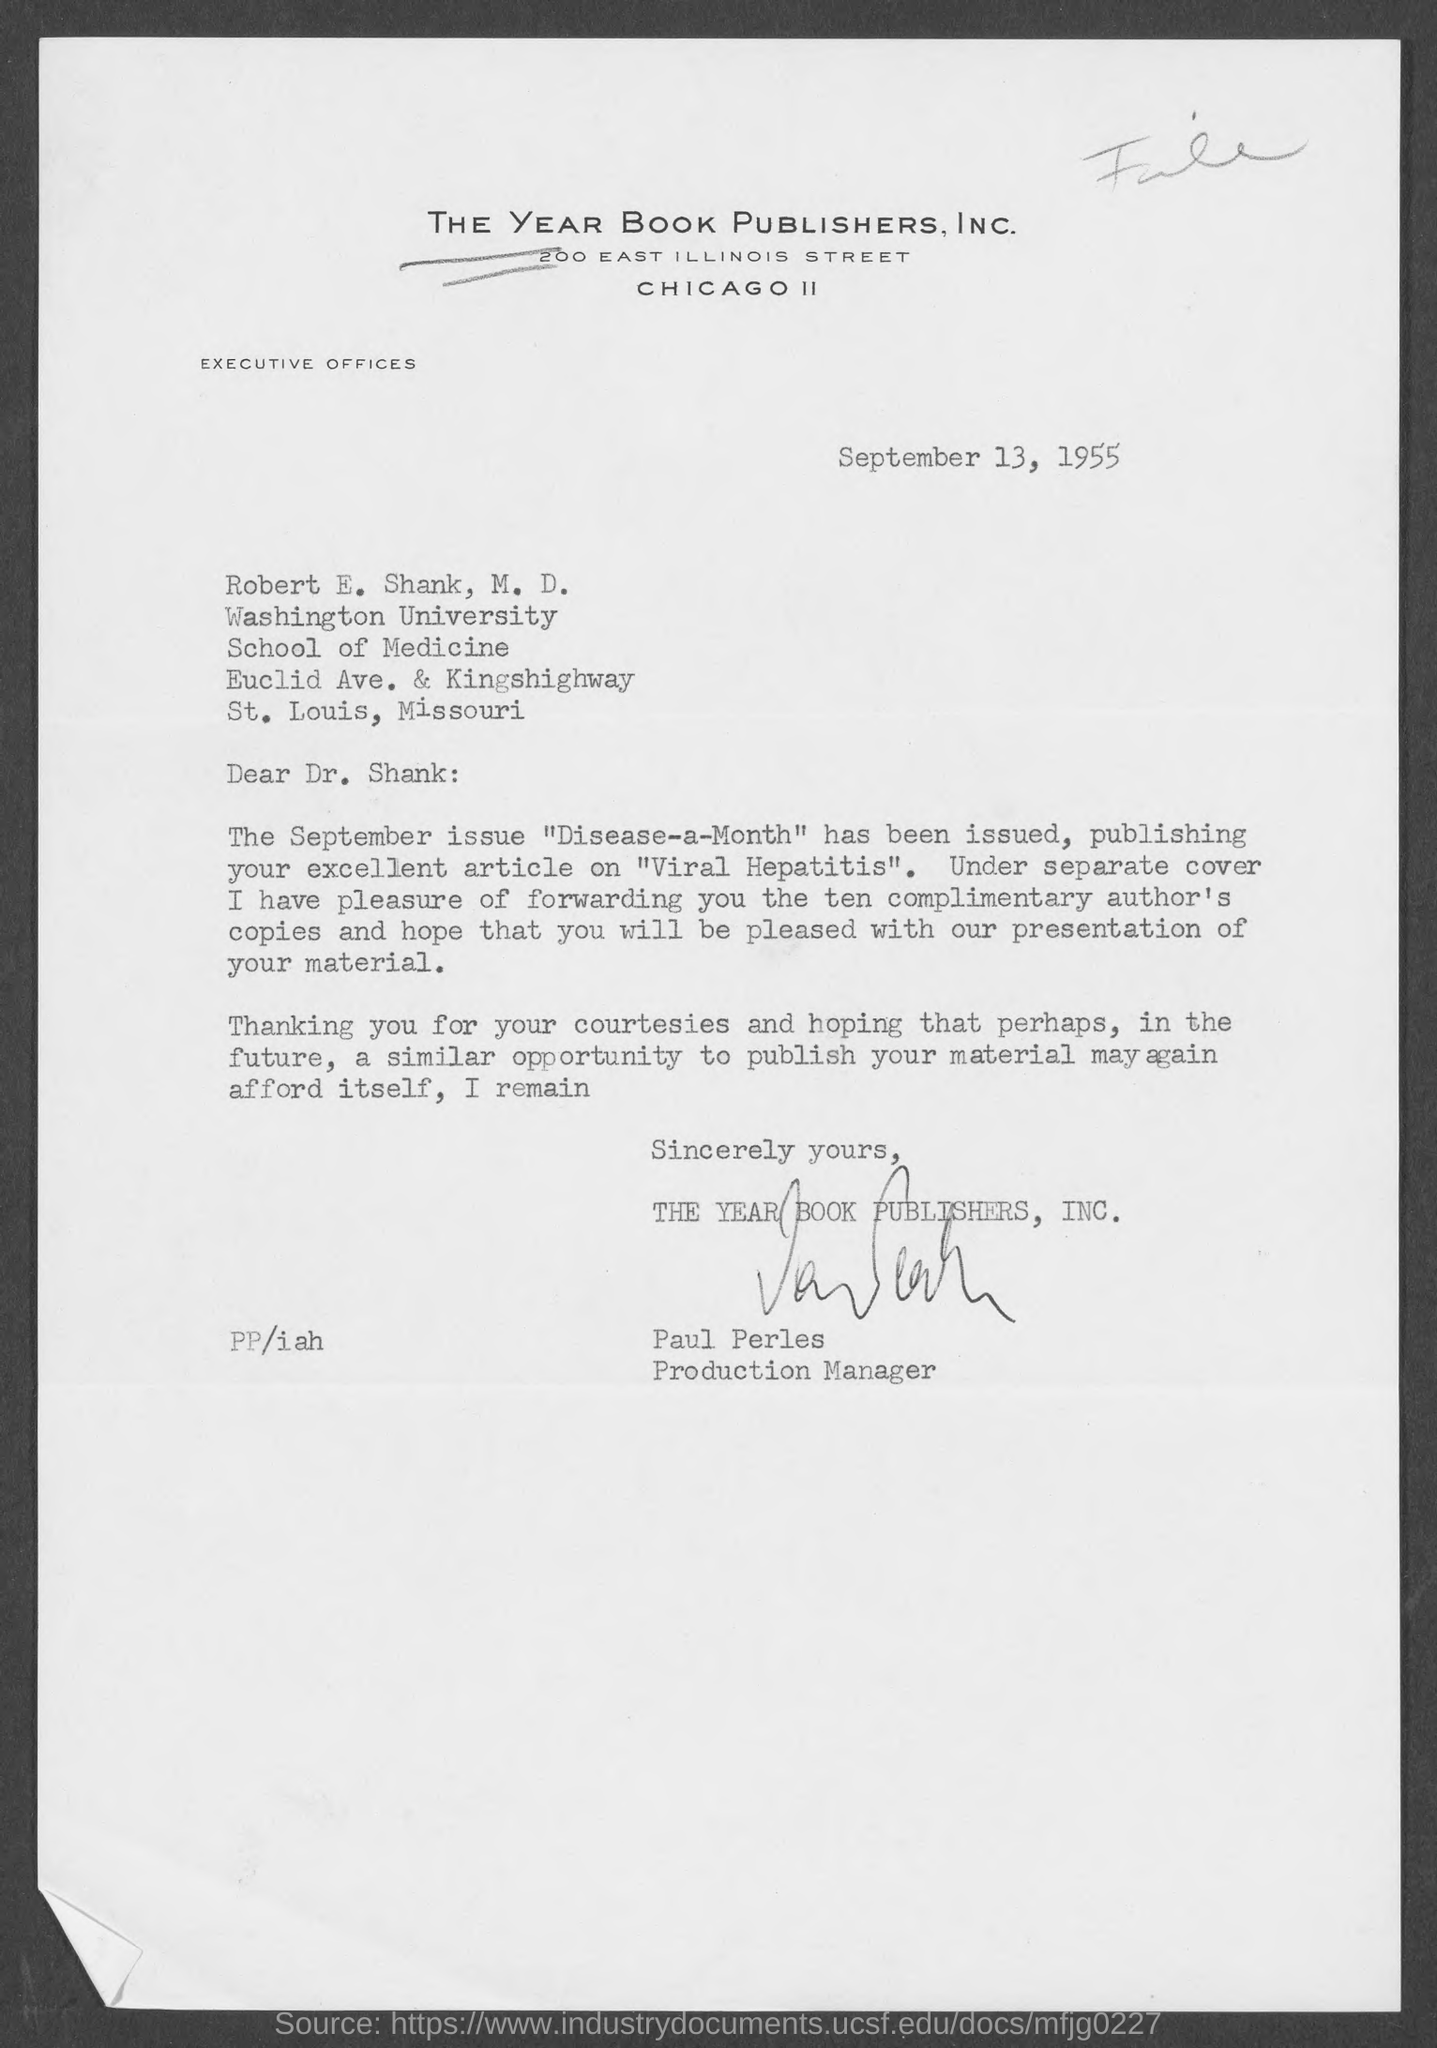What is the Company Name ?
Your answer should be compact. The Year Book Publishers, Inc. What is the Date mentioned in the top of the document ?
Make the answer very short. September 13, 1955. 